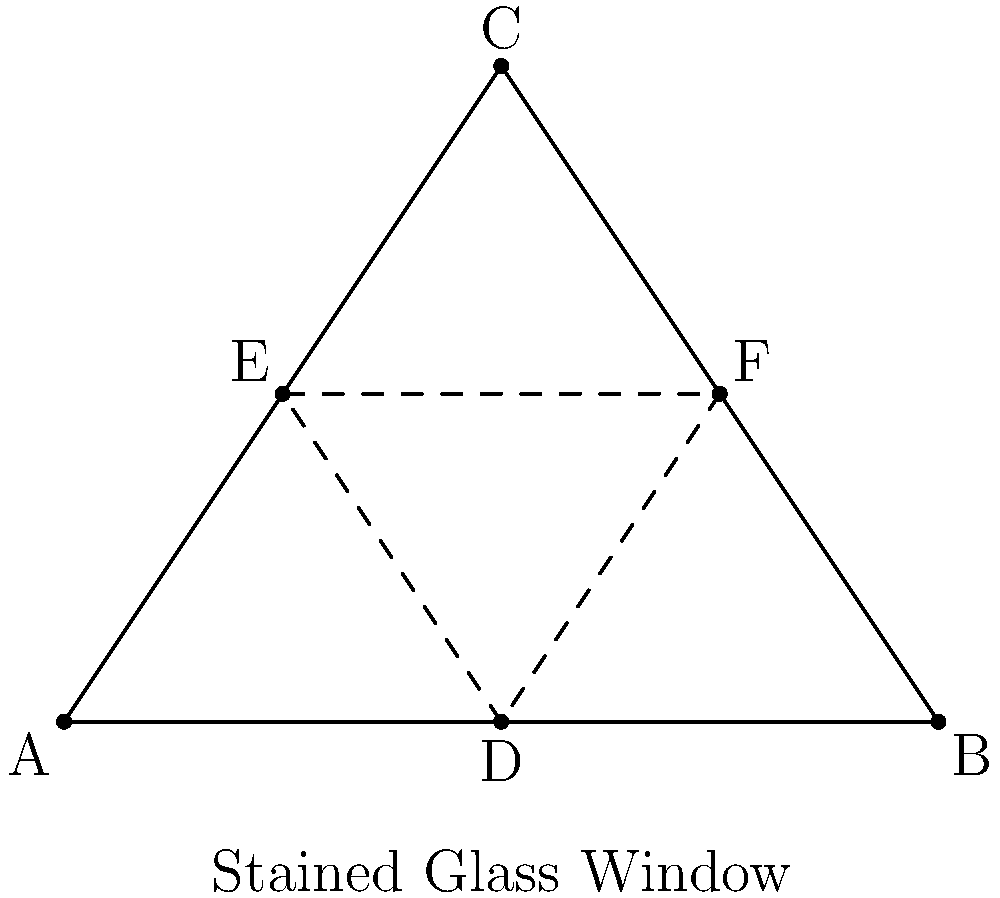In a stained glass window of your church, a large triangular pane $ABC$ is divided into four smaller triangles by lines connecting the midpoints of its sides, as shown in the diagram. If the area of triangle $DEF$ is 16 square feet, what is the area of the entire window pane $ABC$? Let's approach this step-by-step:

1) First, recall that when we connect the midpoints of a triangle's sides, the resulting inner triangle (DEF in this case) is similar to the original triangle (ABC) with a scale factor of 1:2.

2) This means that the area of triangle DEF is $\frac{1}{4}$ of the area of triangle ABC.

3) We are given that the area of triangle DEF is 16 square feet.

4) Let's call the area of triangle ABC $x$ square feet.

5) We can set up the equation:
   $\frac{1}{4}x = 16$

6) Solving for $x$:
   $x = 16 \times 4 = 64$

Therefore, the area of the entire window pane ABC is 64 square feet.
Answer: 64 square feet 